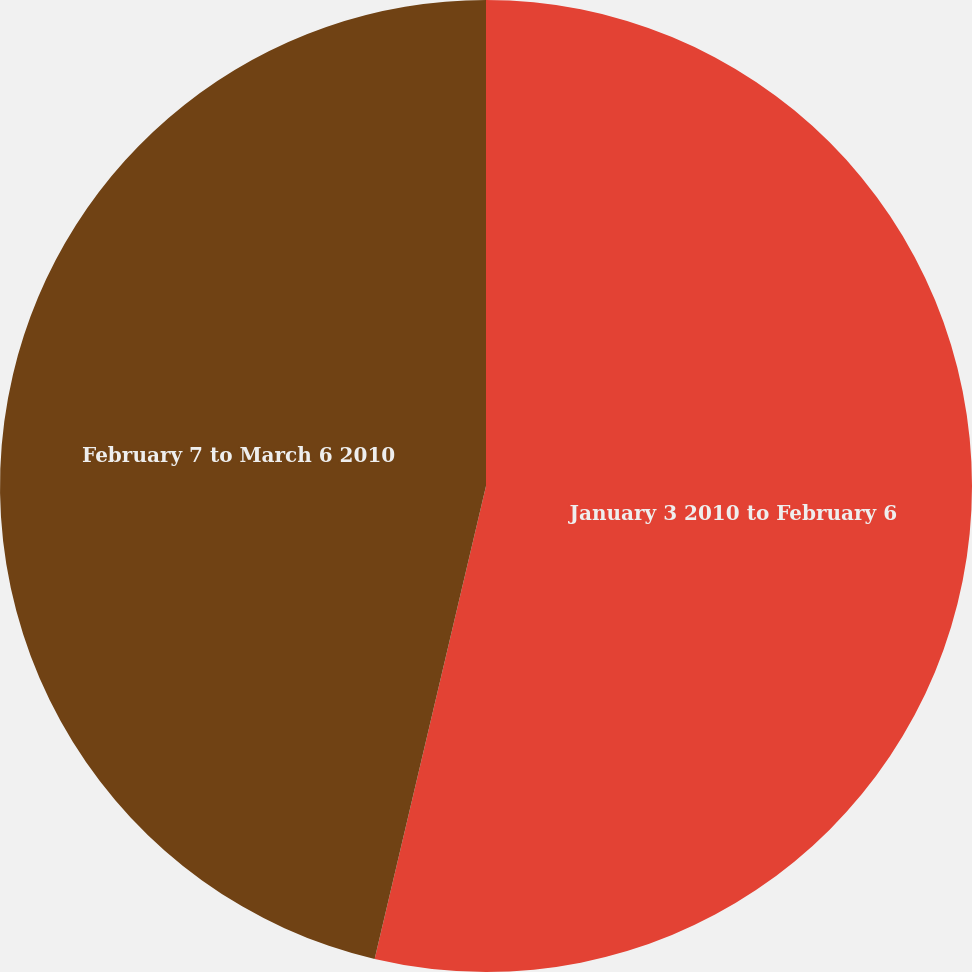<chart> <loc_0><loc_0><loc_500><loc_500><pie_chart><fcel>January 3 2010 to February 6<fcel>February 7 to March 6 2010<nl><fcel>53.68%<fcel>46.32%<nl></chart> 